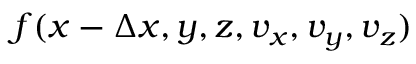Convert formula to latex. <formula><loc_0><loc_0><loc_500><loc_500>f ( x - \Delta x , y , z , v _ { x } , v _ { y } , v _ { z } )</formula> 